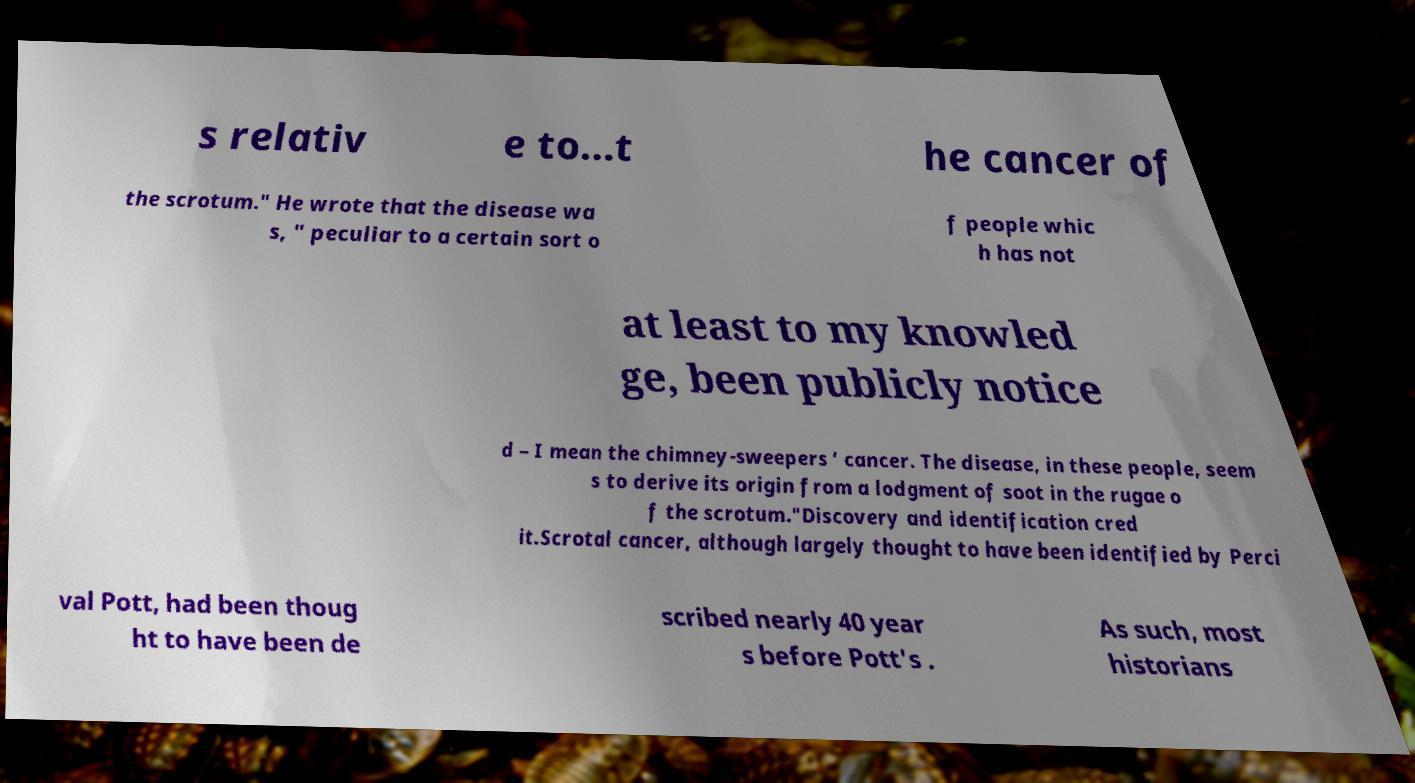There's text embedded in this image that I need extracted. Can you transcribe it verbatim? s relativ e to…t he cancer of the scrotum." He wrote that the disease wa s, " peculiar to a certain sort o f people whic h has not at least to my knowled ge, been publicly notice d – I mean the chimney-sweepers ’ cancer. The disease, in these people, seem s to derive its origin from a lodgment of soot in the rugae o f the scrotum."Discovery and identification cred it.Scrotal cancer, although largely thought to have been identified by Perci val Pott, had been thoug ht to have been de scribed nearly 40 year s before Pott's . As such, most historians 